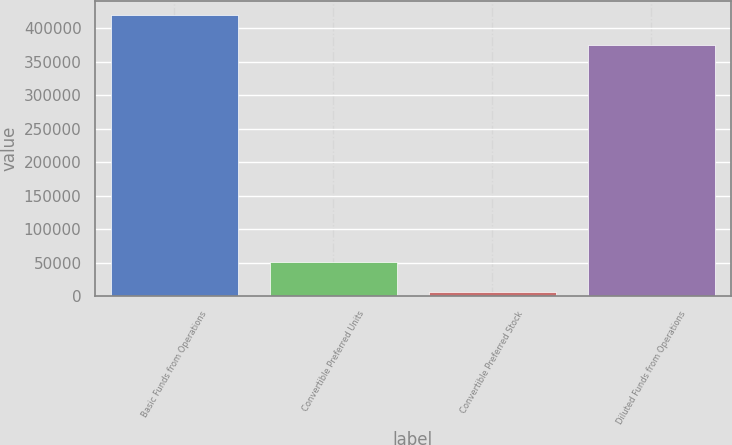Convert chart. <chart><loc_0><loc_0><loc_500><loc_500><bar_chart><fcel>Basic Funds from Operations<fcel>Convertible Preferred Units<fcel>Convertible Preferred Stock<fcel>Diluted Funds from Operations<nl><fcel>419308<fcel>50854.4<fcel>6592<fcel>375046<nl></chart> 